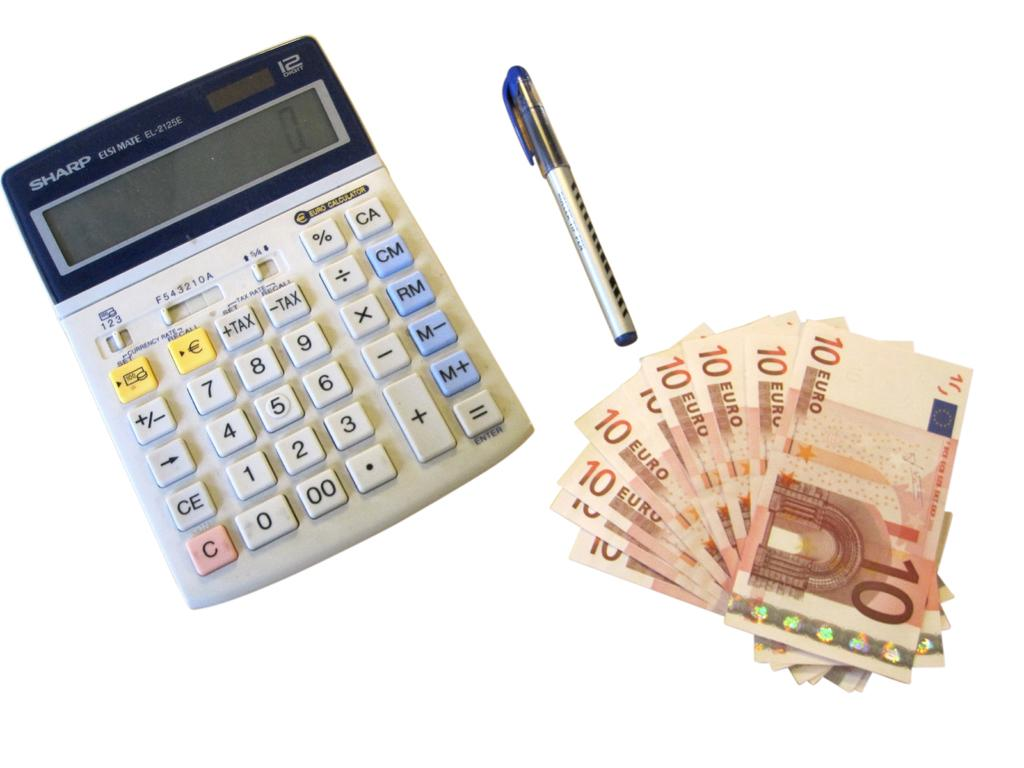<image>
Render a clear and concise summary of the photo. a Sharp calculator next to several 10 Euro bills 